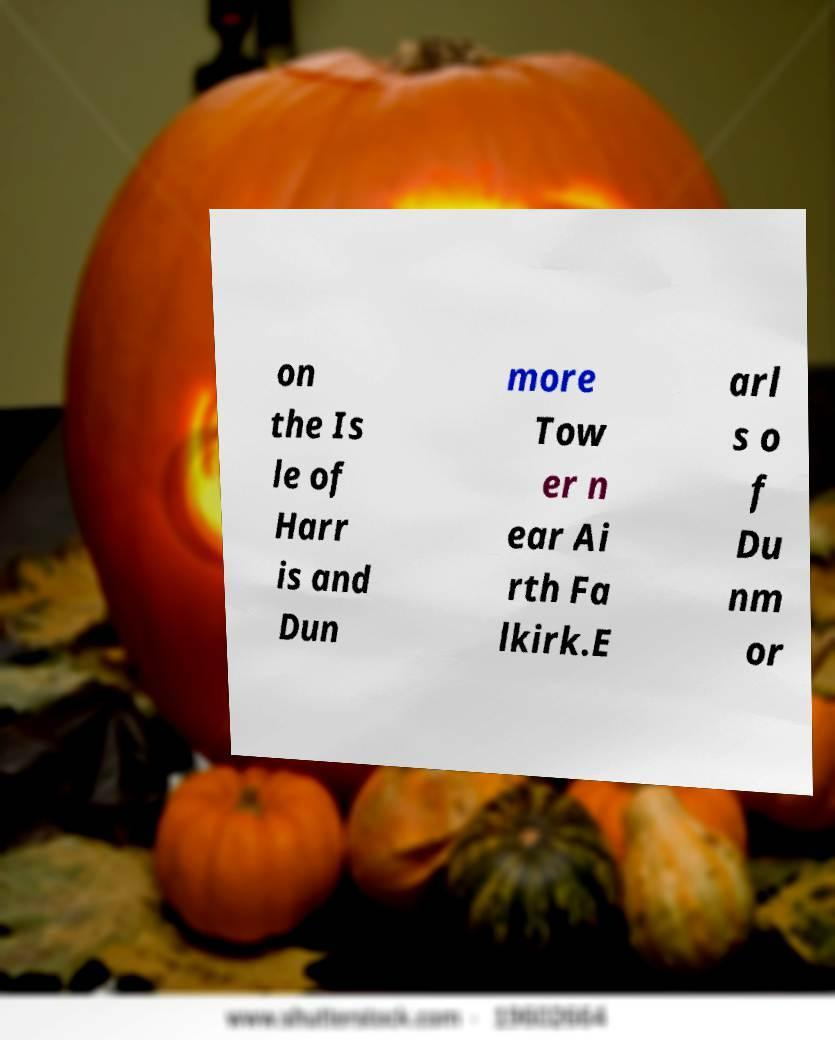Could you extract and type out the text from this image? on the Is le of Harr is and Dun more Tow er n ear Ai rth Fa lkirk.E arl s o f Du nm or 